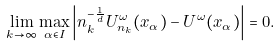Convert formula to latex. <formula><loc_0><loc_0><loc_500><loc_500>\lim _ { k \to \infty } \max _ { \alpha \in I } \left | n _ { k } ^ { - \frac { 1 } { d } } U _ { n _ { k } } ^ { \omega } ( x _ { \alpha } ) - U ^ { \omega } ( x _ { \alpha } ) \right | = 0 .</formula> 